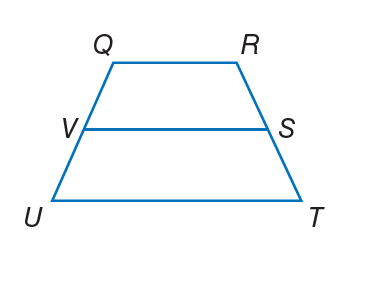Answer the mathemtical geometry problem and directly provide the correct option letter.
Question: For trapezoid Q R T U, V and S are midpoints of the legs. If Q R = 2 and V S = 7, find U T.
Choices: A: 10 B: 11 C: 12 D: 22 C 